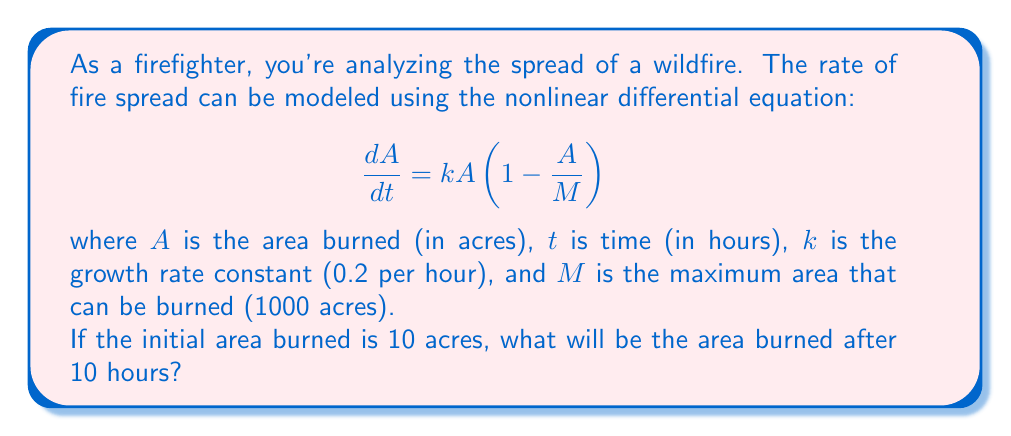Can you answer this question? To solve this problem, we need to use the logistic growth model, which is a nonlinear differential equation. Let's approach this step-by-step:

1) The given equation is:
   $$\frac{dA}{dt} = kA(1 - \frac{A}{M})$$

2) We're given:
   $k = 0.2$ per hour
   $M = 1000$ acres
   $A(0) = 10$ acres (initial condition)
   We need to find $A(10)$

3) The solution to this logistic equation is:
   $$A(t) = \frac{M}{1 + (\frac{M}{A_0} - 1)e^{-kt}}$$

   Where $A_0$ is the initial area burned.

4) Let's substitute our values:
   $$A(t) = \frac{1000}{1 + (\frac{1000}{10} - 1)e^{-0.2t}}$$

5) Simplify:
   $$A(t) = \frac{1000}{1 + 99e^{-0.2t}}$$

6) Now, we want to find $A(10)$, so let's substitute $t = 10$:
   $$A(10) = \frac{1000}{1 + 99e^{-0.2(10)}}$$

7) Calculate:
   $$A(10) = \frac{1000}{1 + 99e^{-2}} \approx 132.9$$

Therefore, after 10 hours, approximately 132.9 acres will be burned.
Answer: 132.9 acres 